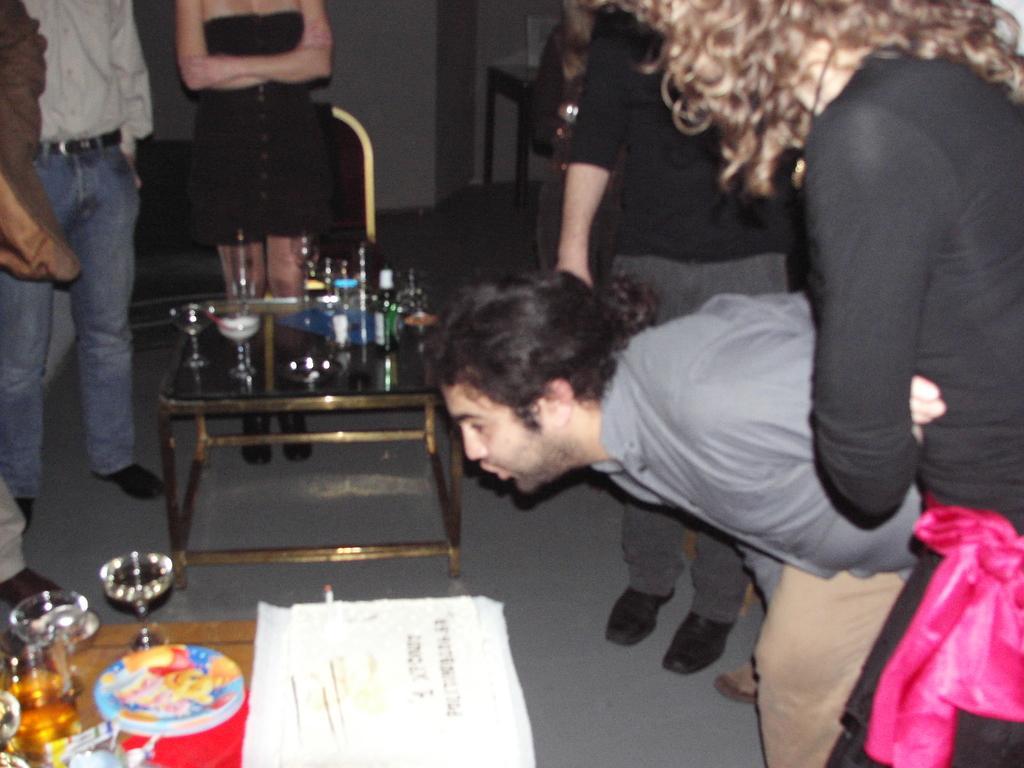Describe this image in one or two sentences. People are standing near the table and on the table there are bottles and glass. 